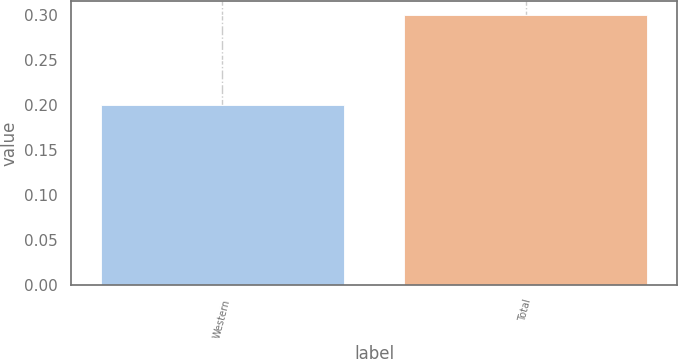Convert chart. <chart><loc_0><loc_0><loc_500><loc_500><bar_chart><fcel>Western<fcel>Total<nl><fcel>0.2<fcel>0.3<nl></chart> 